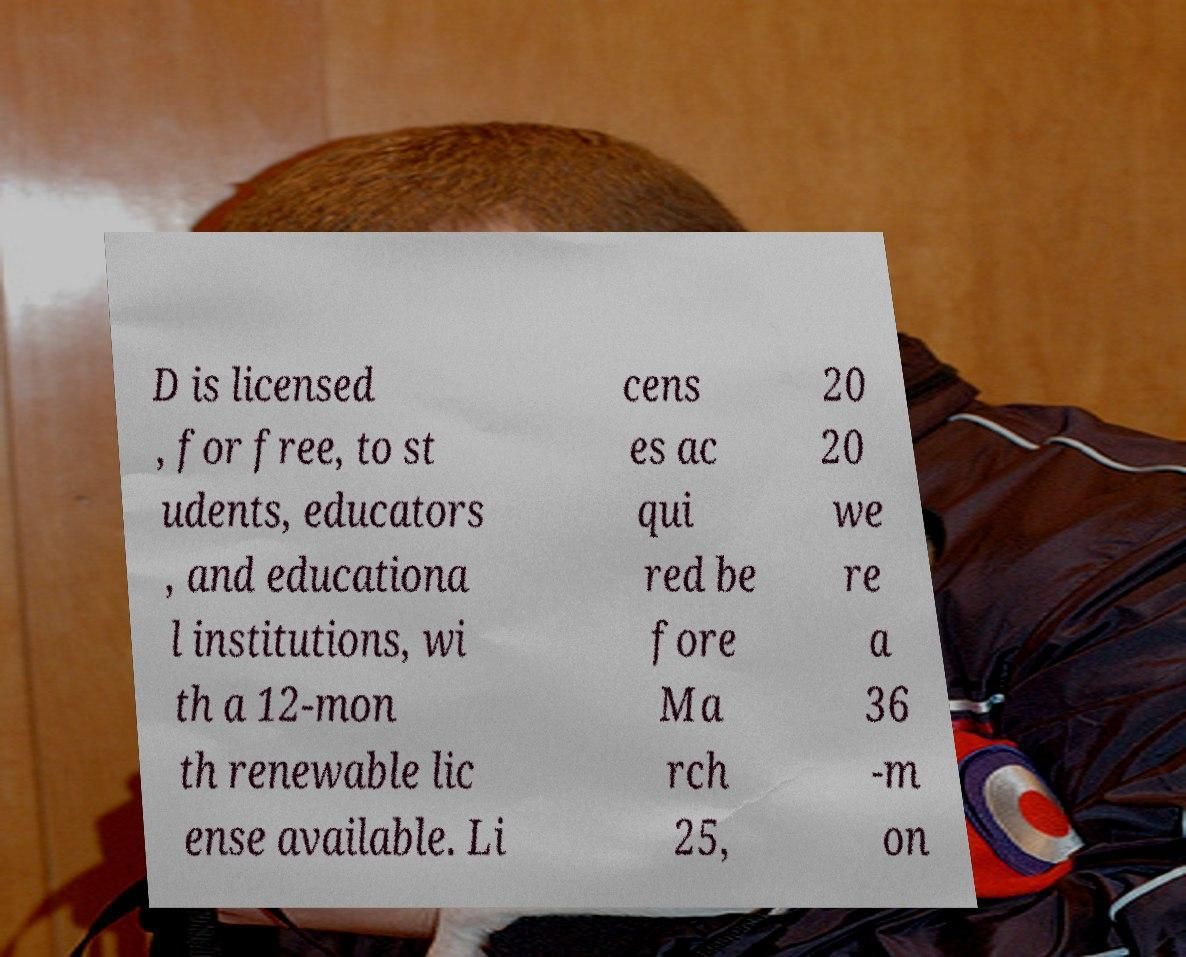Can you accurately transcribe the text from the provided image for me? D is licensed , for free, to st udents, educators , and educationa l institutions, wi th a 12-mon th renewable lic ense available. Li cens es ac qui red be fore Ma rch 25, 20 20 we re a 36 -m on 